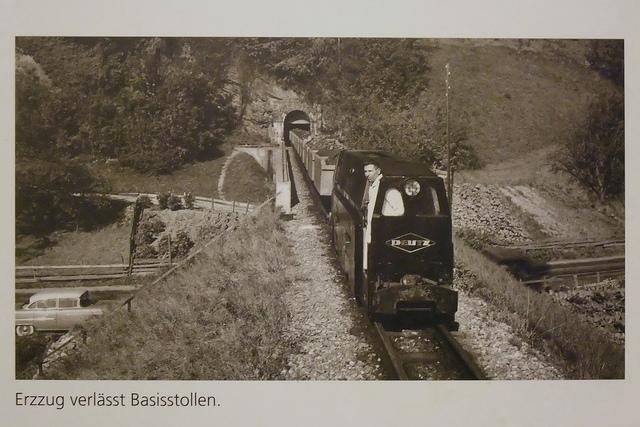What is the race of the man on the train?
Short answer required. White. What language is this photo captioned with?
Answer briefly. German. Is the train in the mountains?
Keep it brief. Yes. What is in the corner of the picture?
Be succinct. Trees. 